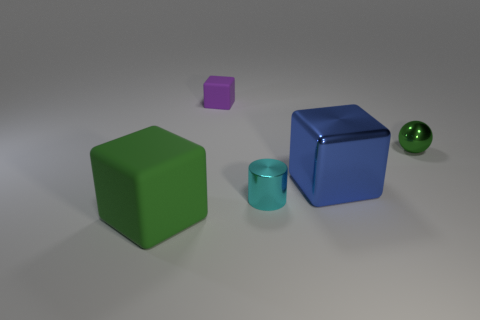Add 3 blocks. How many objects exist? 8 Subtract all cylinders. How many objects are left? 4 Add 4 green metallic spheres. How many green metallic spheres exist? 5 Subtract 1 green balls. How many objects are left? 4 Subtract all large red rubber cylinders. Subtract all big blue objects. How many objects are left? 4 Add 1 cylinders. How many cylinders are left? 2 